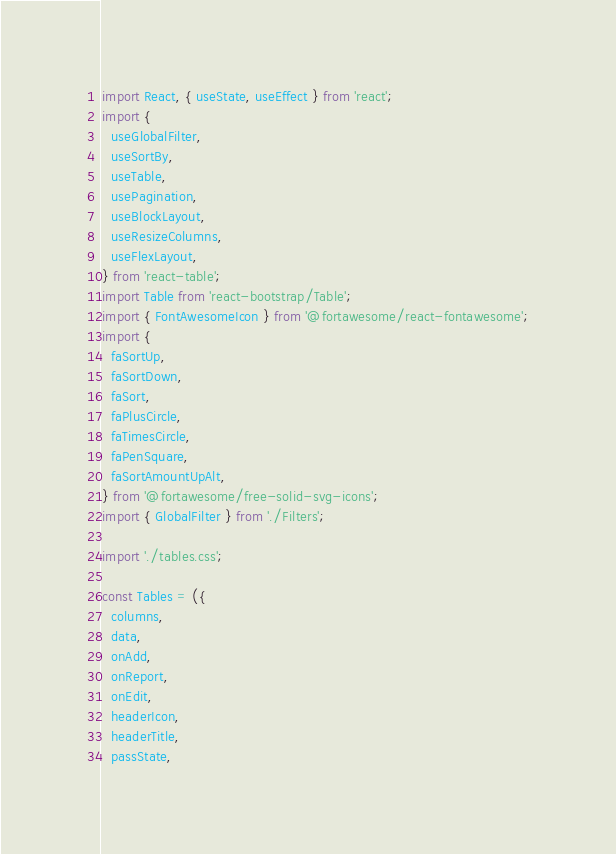<code> <loc_0><loc_0><loc_500><loc_500><_JavaScript_>import React, { useState, useEffect } from 'react';
import {
  useGlobalFilter,
  useSortBy,
  useTable,
  usePagination,
  useBlockLayout,
  useResizeColumns,
  useFlexLayout,
} from 'react-table';
import Table from 'react-bootstrap/Table';
import { FontAwesomeIcon } from '@fortawesome/react-fontawesome';
import {
  faSortUp,
  faSortDown,
  faSort,
  faPlusCircle,
  faTimesCircle,
  faPenSquare,
  faSortAmountUpAlt,
} from '@fortawesome/free-solid-svg-icons';
import { GlobalFilter } from './Filters';

import './tables.css';

const Tables = ({
  columns,
  data,
  onAdd,
  onReport,
  onEdit,
  headerIcon,
  headerTitle,
  passState,</code> 